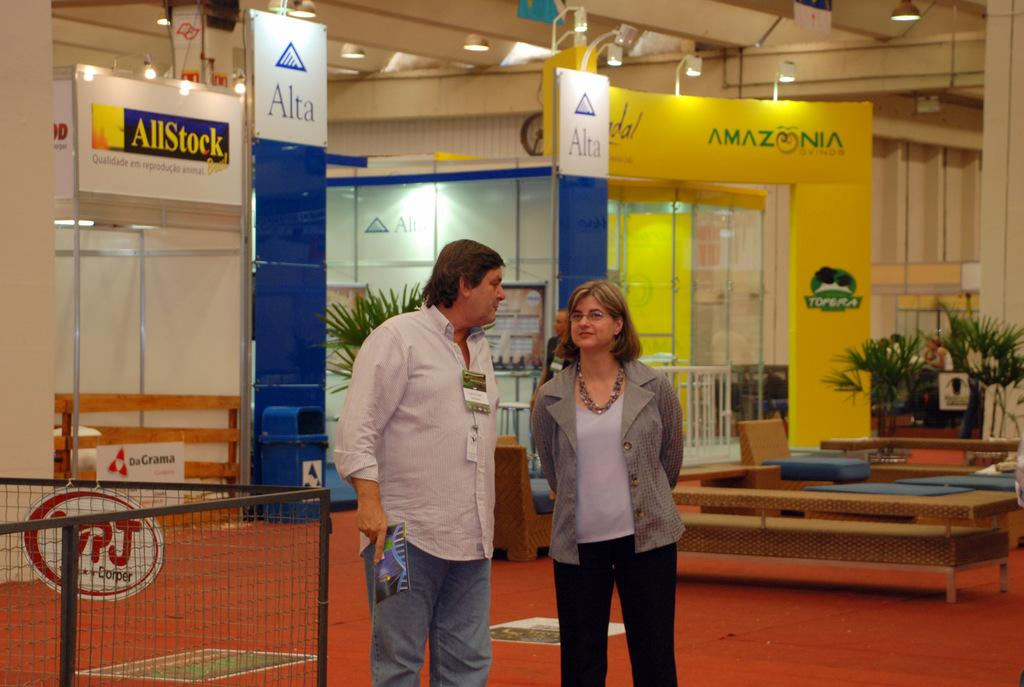How many people are in the image? There are two persons standing in the image. What can be seen in the background of the image? Plants and hoardings are visible in the background. What is located at the top of the image? There are lights visible at the top. Where is the dustbin placed in the image? The dustbin is on the left side of the image. What type of grape is being used as a bookmark in the library in the image? There is no grape or library present in the image. What rule is being enforced by the persons in the image? There is no indication of a rule being enforced in the image. 